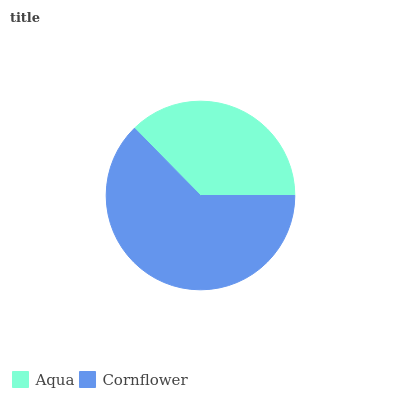Is Aqua the minimum?
Answer yes or no. Yes. Is Cornflower the maximum?
Answer yes or no. Yes. Is Cornflower the minimum?
Answer yes or no. No. Is Cornflower greater than Aqua?
Answer yes or no. Yes. Is Aqua less than Cornflower?
Answer yes or no. Yes. Is Aqua greater than Cornflower?
Answer yes or no. No. Is Cornflower less than Aqua?
Answer yes or no. No. Is Cornflower the high median?
Answer yes or no. Yes. Is Aqua the low median?
Answer yes or no. Yes. Is Aqua the high median?
Answer yes or no. No. Is Cornflower the low median?
Answer yes or no. No. 